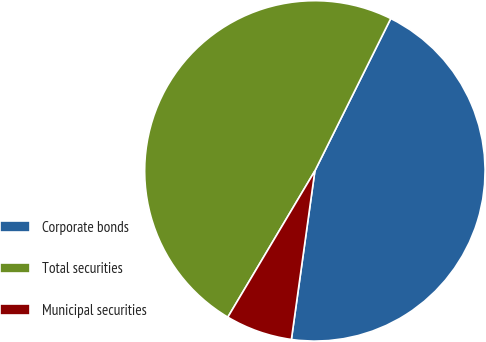Convert chart to OTSL. <chart><loc_0><loc_0><loc_500><loc_500><pie_chart><fcel>Corporate bonds<fcel>Total securities<fcel>Municipal securities<nl><fcel>44.85%<fcel>48.81%<fcel>6.34%<nl></chart> 